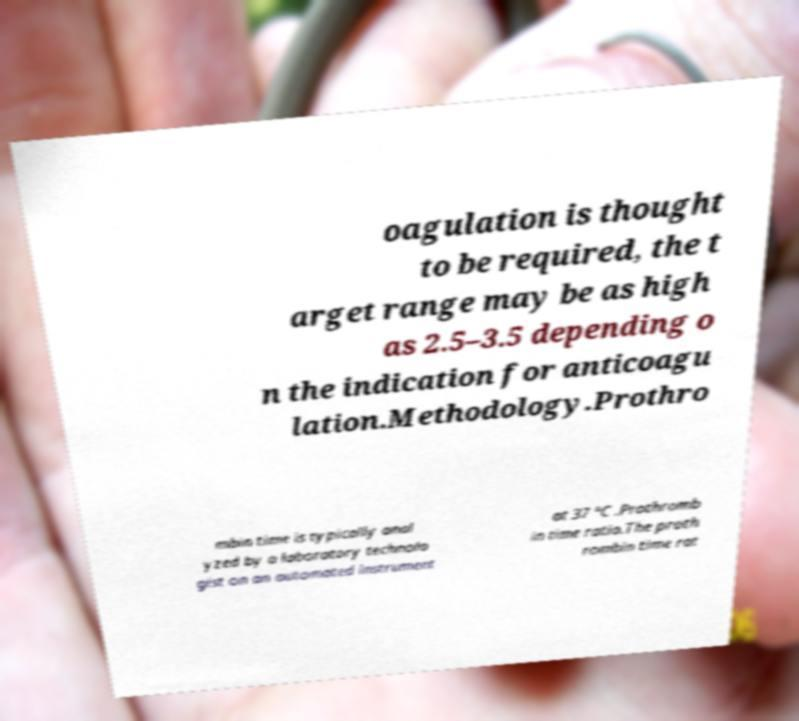Can you accurately transcribe the text from the provided image for me? oagulation is thought to be required, the t arget range may be as high as 2.5–3.5 depending o n the indication for anticoagu lation.Methodology.Prothro mbin time is typically anal yzed by a laboratory technolo gist on an automated instrument at 37 °C .Prothromb in time ratio.The proth rombin time rat 